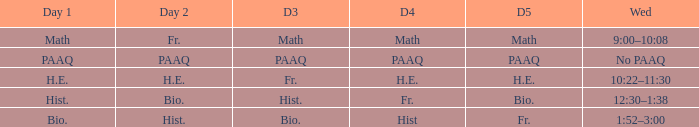What is the Wednesday when day 3 is math? 9:00–10:08. 